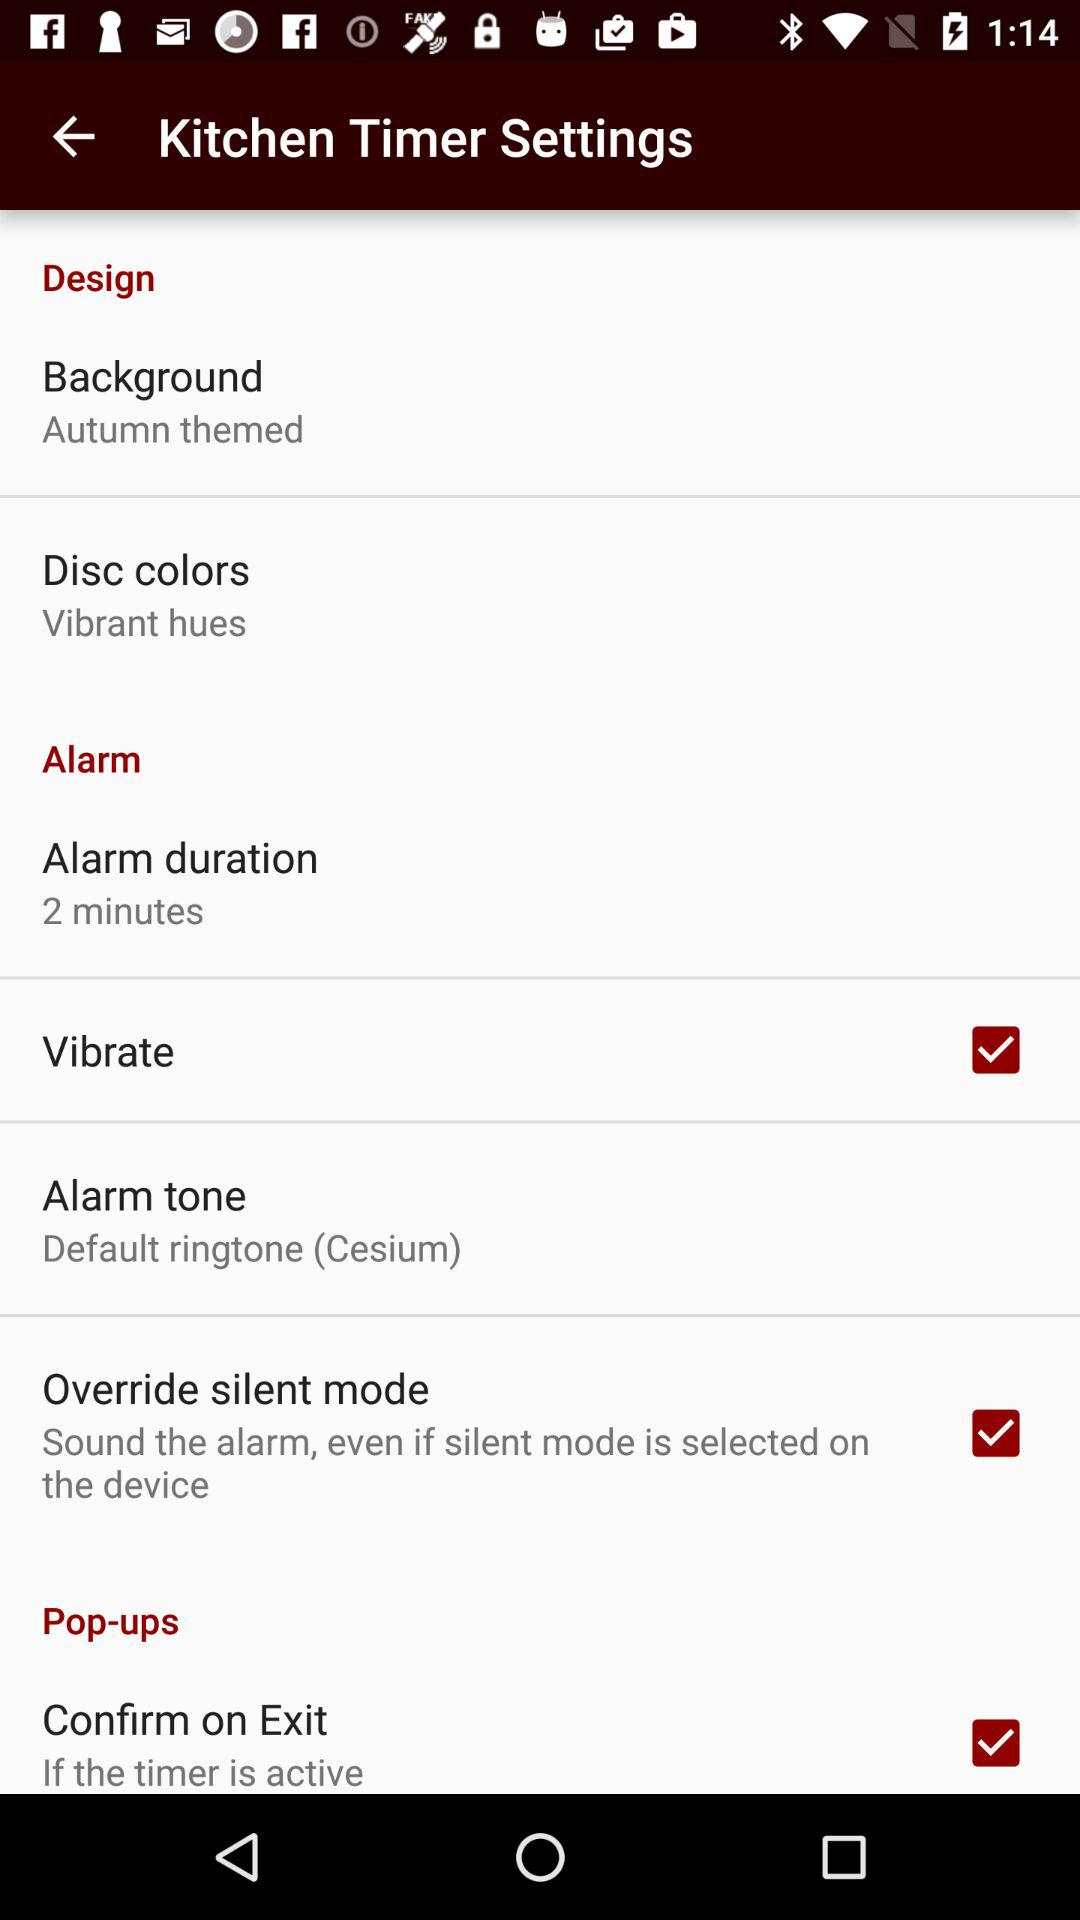What is the duration of the alarm? The duration of the alarm is 2 minutes. 